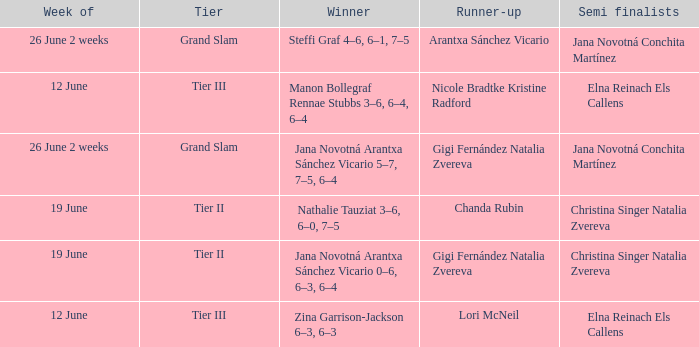When the Tier is listed as tier iii, who is the Winner? Zina Garrison-Jackson 6–3, 6–3, Manon Bollegraf Rennae Stubbs 3–6, 6–4, 6–4. 